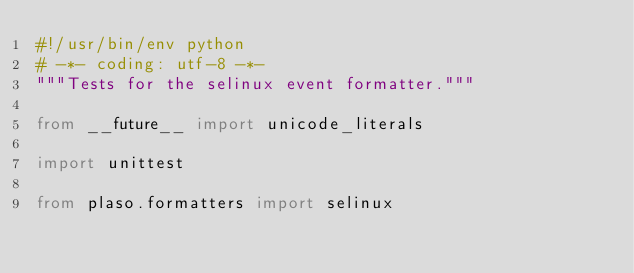<code> <loc_0><loc_0><loc_500><loc_500><_Python_>#!/usr/bin/env python
# -*- coding: utf-8 -*-
"""Tests for the selinux event formatter."""

from __future__ import unicode_literals

import unittest

from plaso.formatters import selinux
</code> 